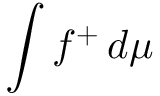<formula> <loc_0><loc_0><loc_500><loc_500>\int f ^ { + } \, d \mu</formula> 